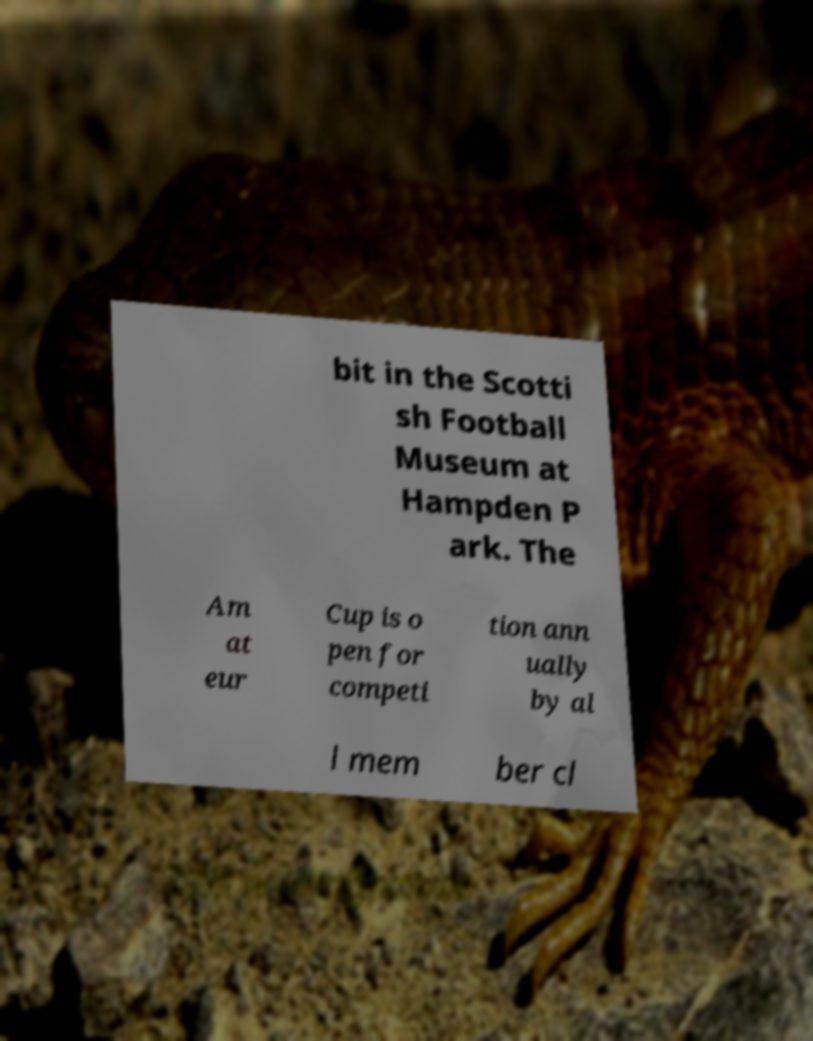There's text embedded in this image that I need extracted. Can you transcribe it verbatim? bit in the Scotti sh Football Museum at Hampden P ark. The Am at eur Cup is o pen for competi tion ann ually by al l mem ber cl 